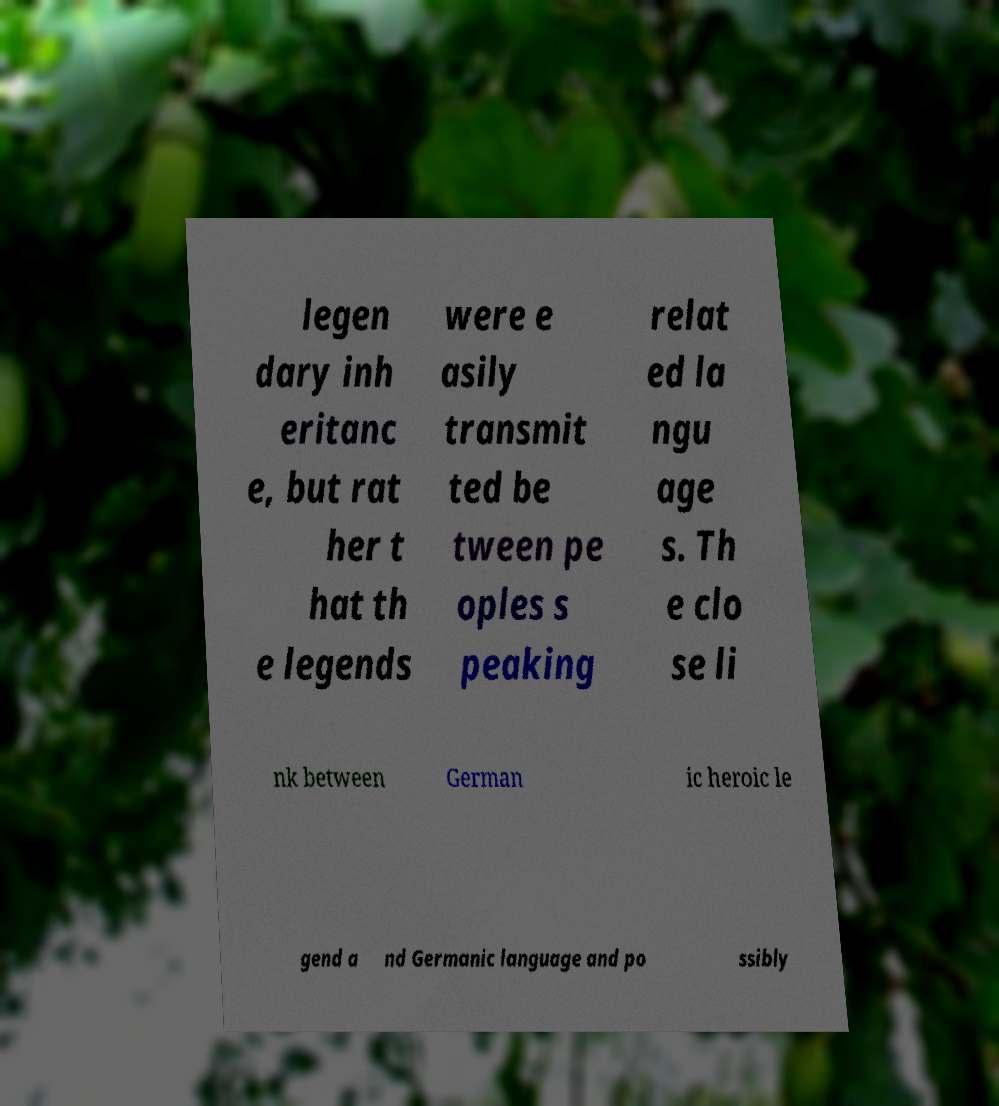Can you read and provide the text displayed in the image?This photo seems to have some interesting text. Can you extract and type it out for me? legen dary inh eritanc e, but rat her t hat th e legends were e asily transmit ted be tween pe oples s peaking relat ed la ngu age s. Th e clo se li nk between German ic heroic le gend a nd Germanic language and po ssibly 